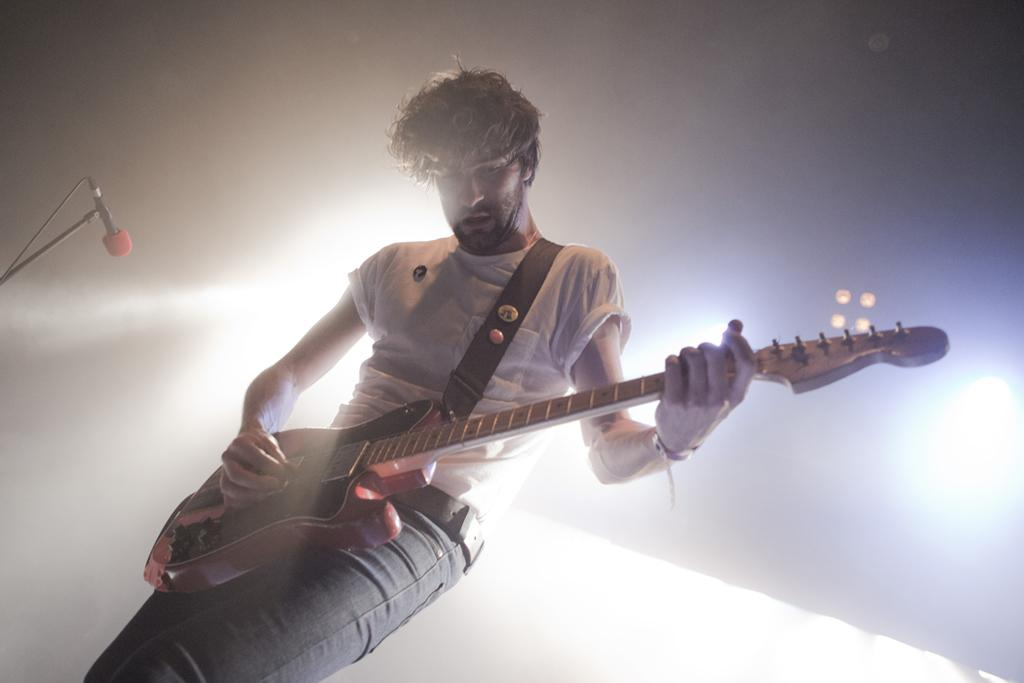What is the main subject of the image? There is a person in the image. Where is the person located in the image? The person is standing in the middle. What is the person wearing in the image? The person is wearing a white shirt and jeans. What is the person doing in the image? The person is playing a guitar. What object is in front of the person in the image? There is a microphone in front of the person. What can be seen behind the person in the image? There are lights visible behind the person. What type of summer activity is the person participating in the image? The image does not depict a summer activity, as there is no indication of the season or any specific summer-related elements. What is the base of the microphone made of in the image? There is no information provided about the base of the microphone, so it cannot be determined from the image. 